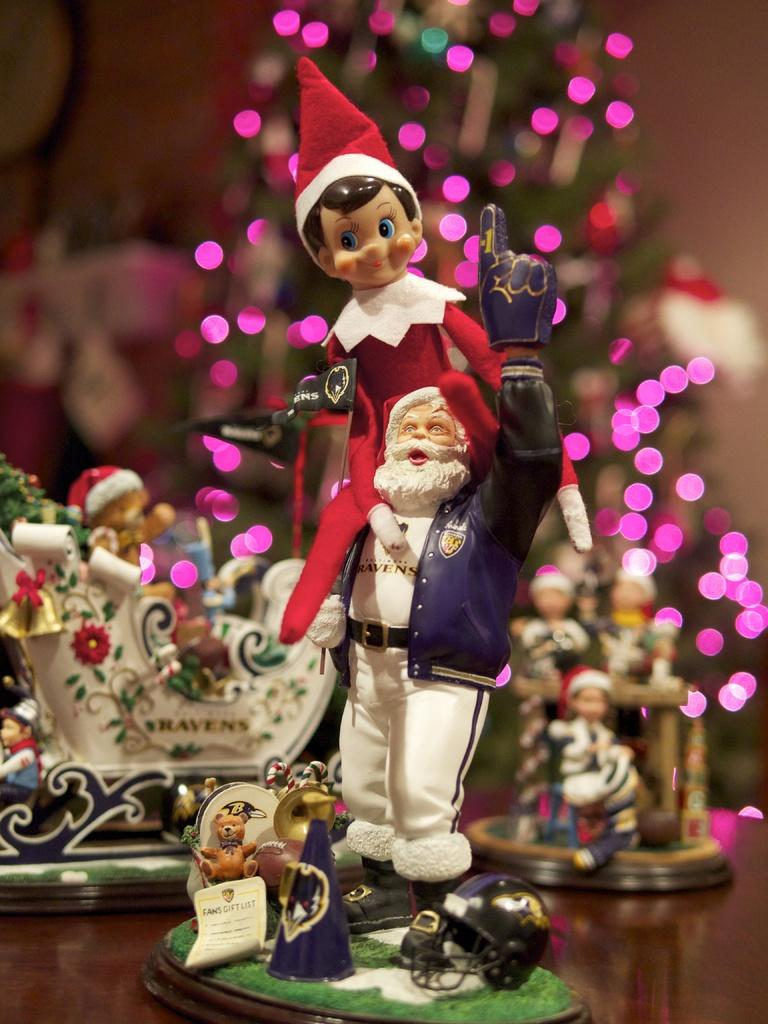What objects are in the foreground of the image? There are toys in the foreground of the image. What is located in the background of the image? There is a Christmas tree with lights in the background of the image. What type of bottle is being used as a punishment in the image? There is no bottle or punishment present in the image; it features toys in the foreground and a Christmas tree with lights in the background. 